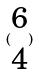<formula> <loc_0><loc_0><loc_500><loc_500>( \begin{matrix} 6 \\ 4 \end{matrix} )</formula> 